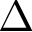Convert formula to latex. <formula><loc_0><loc_0><loc_500><loc_500>\Delta</formula> 